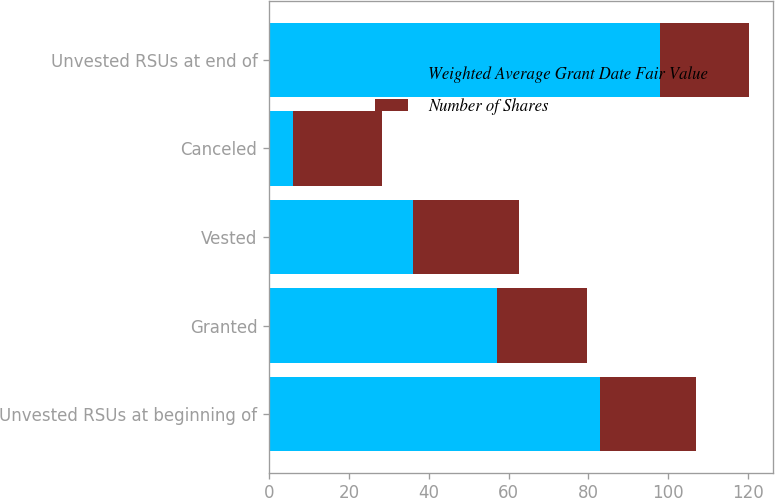<chart> <loc_0><loc_0><loc_500><loc_500><stacked_bar_chart><ecel><fcel>Unvested RSUs at beginning of<fcel>Granted<fcel>Vested<fcel>Canceled<fcel>Unvested RSUs at end of<nl><fcel>Weighted Average Grant Date Fair Value<fcel>83<fcel>57<fcel>36<fcel>6<fcel>98<nl><fcel>Number of Shares<fcel>23.83<fcel>22.72<fcel>26.67<fcel>22.19<fcel>22.29<nl></chart> 